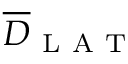<formula> <loc_0><loc_0><loc_500><loc_500>\overline { D } _ { L A T }</formula> 